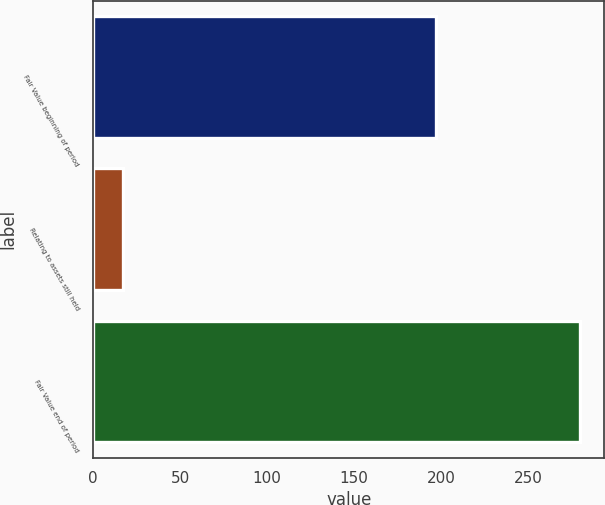Convert chart to OTSL. <chart><loc_0><loc_0><loc_500><loc_500><bar_chart><fcel>Fair Value beginning of period<fcel>Relating to assets still held<fcel>Fair Value end of period<nl><fcel>197<fcel>17<fcel>280<nl></chart> 